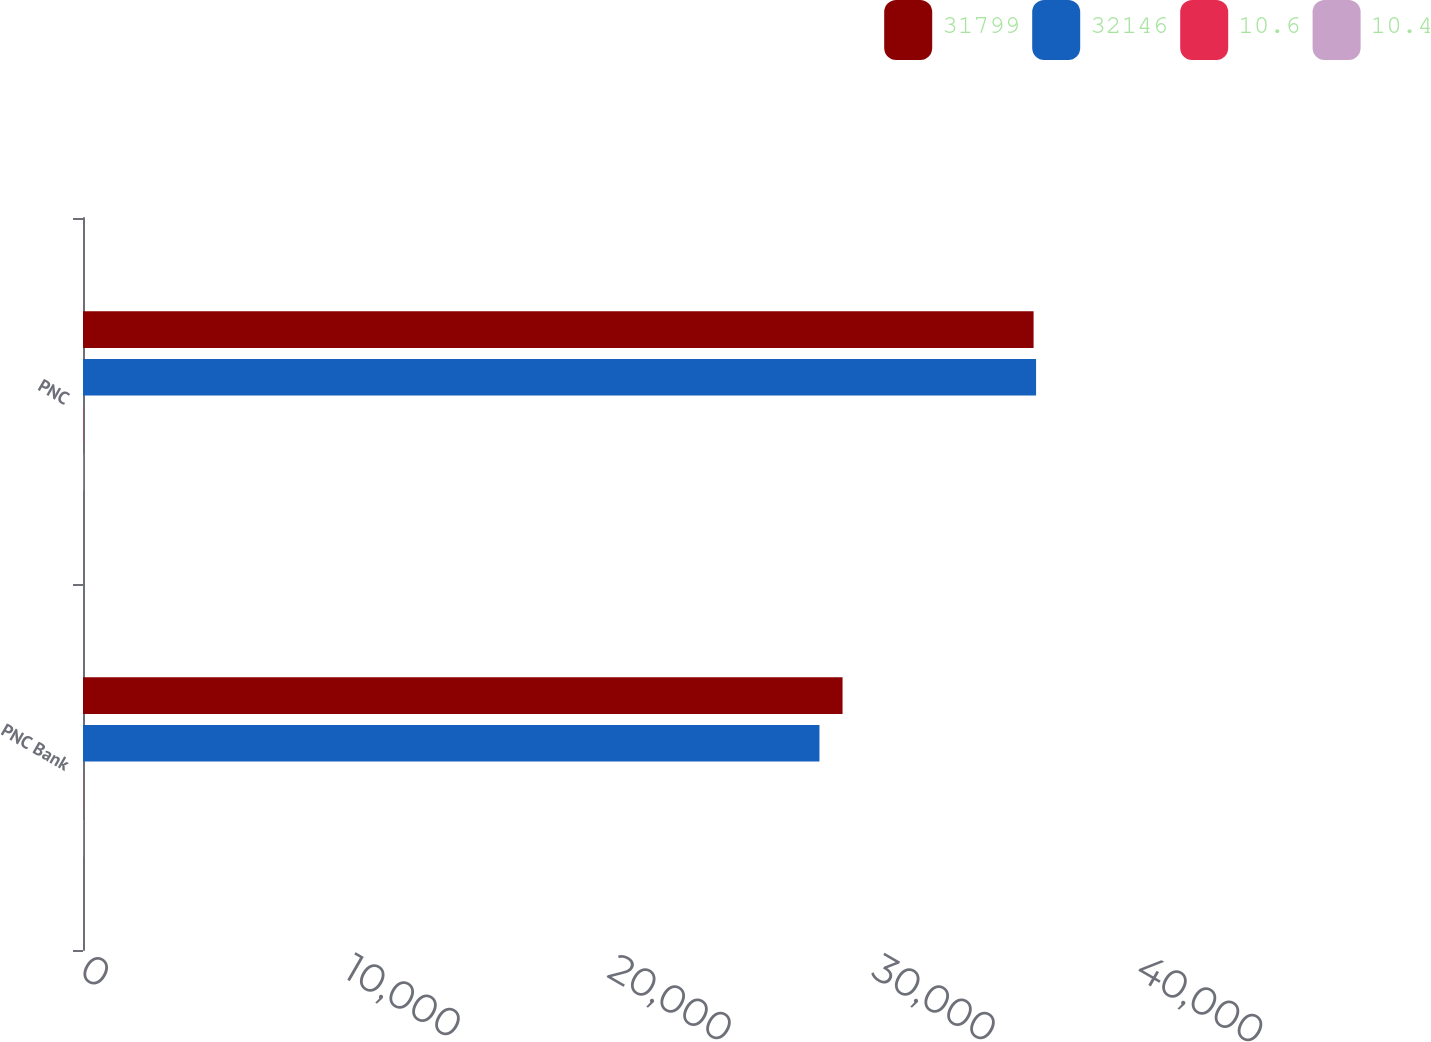<chart> <loc_0><loc_0><loc_500><loc_500><stacked_bar_chart><ecel><fcel>PNC Bank<fcel>PNC<nl><fcel>31799<fcel>28771<fcel>36007<nl><fcel>32146<fcel>27896<fcel>36101<nl><fcel>10.6<fcel>9.7<fcel>11.6<nl><fcel>10.4<fcel>9.7<fcel>12<nl></chart> 